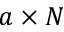Convert formula to latex. <formula><loc_0><loc_0><loc_500><loc_500>a \times N</formula> 